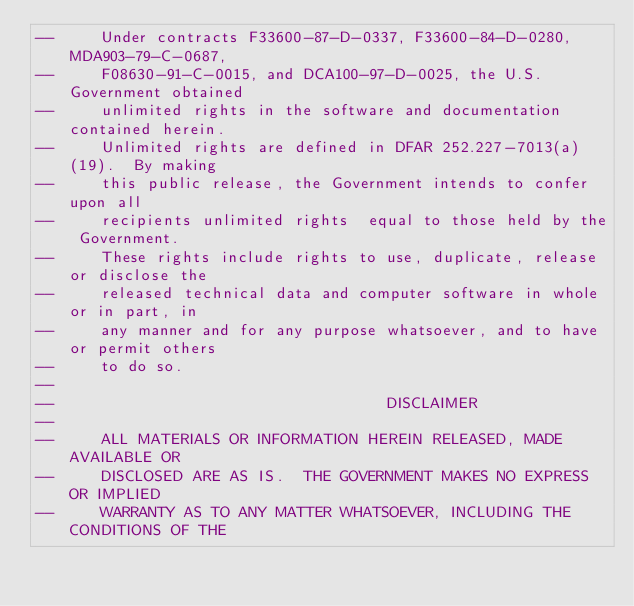<code> <loc_0><loc_0><loc_500><loc_500><_Ada_>--     Under contracts F33600-87-D-0337, F33600-84-D-0280, MDA903-79-C-0687,
--     F08630-91-C-0015, and DCA100-97-D-0025, the U.S. Government obtained 
--     unlimited rights in the software and documentation contained herein.
--     Unlimited rights are defined in DFAR 252.227-7013(a)(19).  By making 
--     this public release, the Government intends to confer upon all 
--     recipients unlimited rights  equal to those held by the Government.  
--     These rights include rights to use, duplicate, release or disclose the 
--     released technical data and computer software in whole or in part, in 
--     any manner and for any purpose whatsoever, and to have or permit others 
--     to do so.
--
--                                    DISCLAIMER
--
--     ALL MATERIALS OR INFORMATION HEREIN RELEASED, MADE AVAILABLE OR
--     DISCLOSED ARE AS IS.  THE GOVERNMENT MAKES NO EXPRESS OR IMPLIED 
--     WARRANTY AS TO ANY MATTER WHATSOEVER, INCLUDING THE CONDITIONS OF THE</code> 